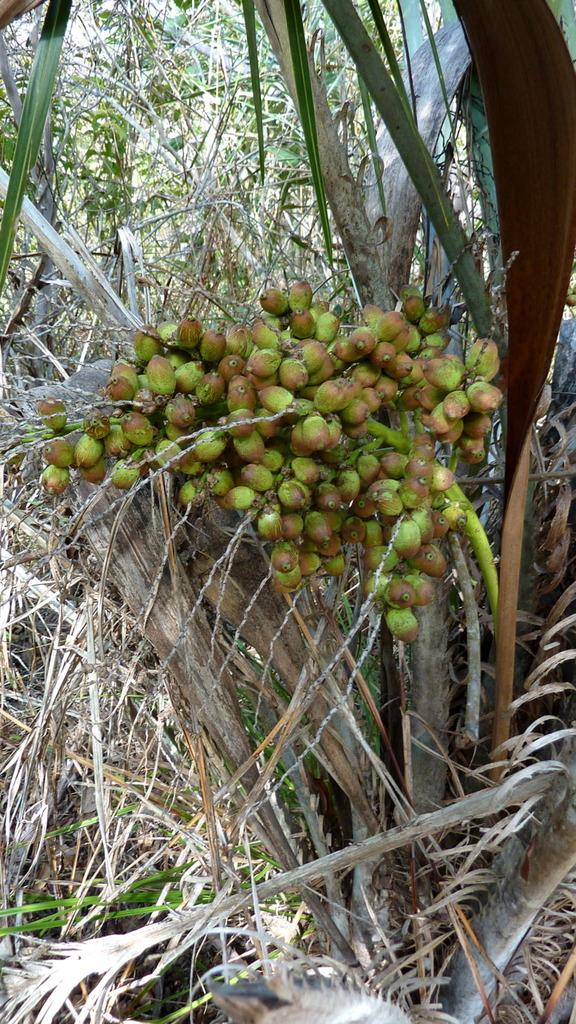What type of tree is present in the image? There is a fruit tree in the image. Can you see a basketball court in the image? There is no basketball court or any reference to a basketball in the image; it features a fruit tree. 